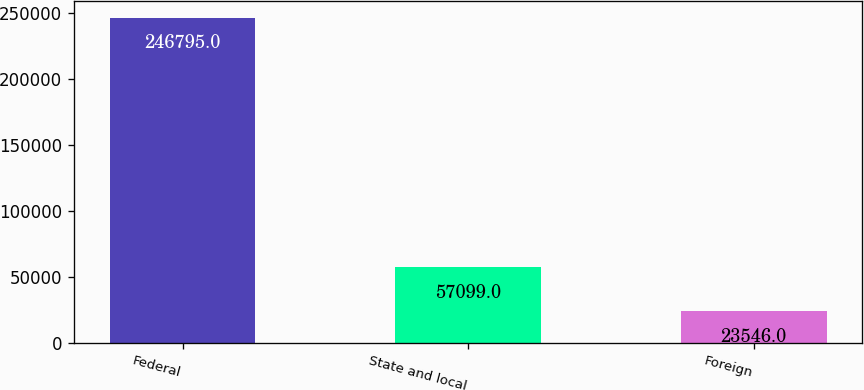Convert chart to OTSL. <chart><loc_0><loc_0><loc_500><loc_500><bar_chart><fcel>Federal<fcel>State and local<fcel>Foreign<nl><fcel>246795<fcel>57099<fcel>23546<nl></chart> 